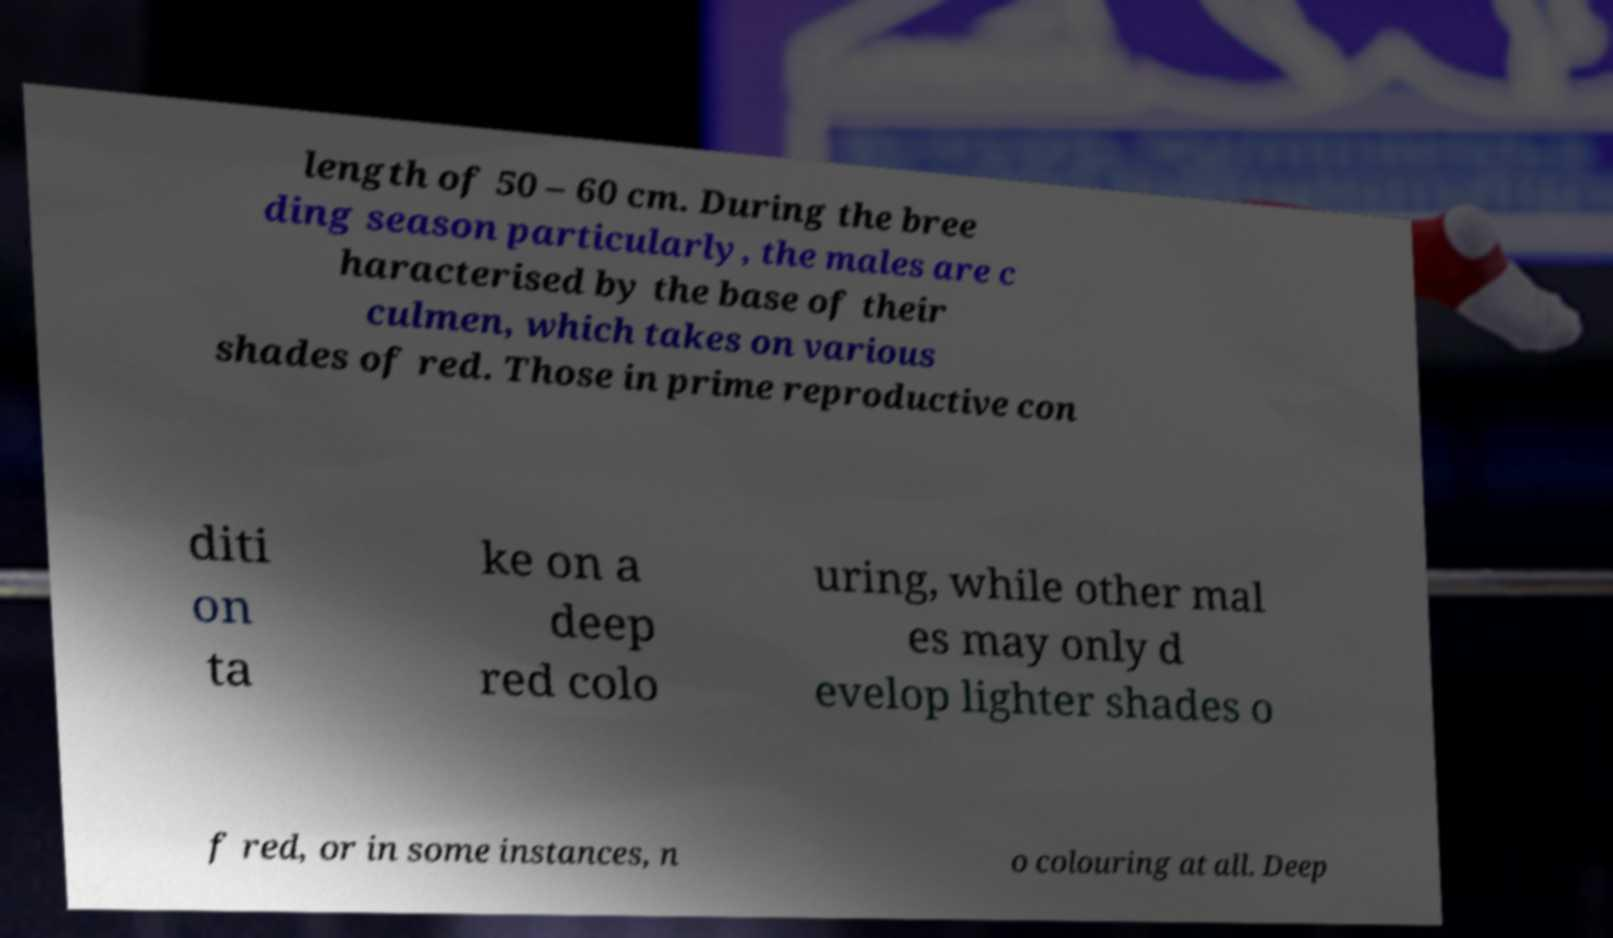Can you read and provide the text displayed in the image?This photo seems to have some interesting text. Can you extract and type it out for me? length of 50 – 60 cm. During the bree ding season particularly, the males are c haracterised by the base of their culmen, which takes on various shades of red. Those in prime reproductive con diti on ta ke on a deep red colo uring, while other mal es may only d evelop lighter shades o f red, or in some instances, n o colouring at all. Deep 